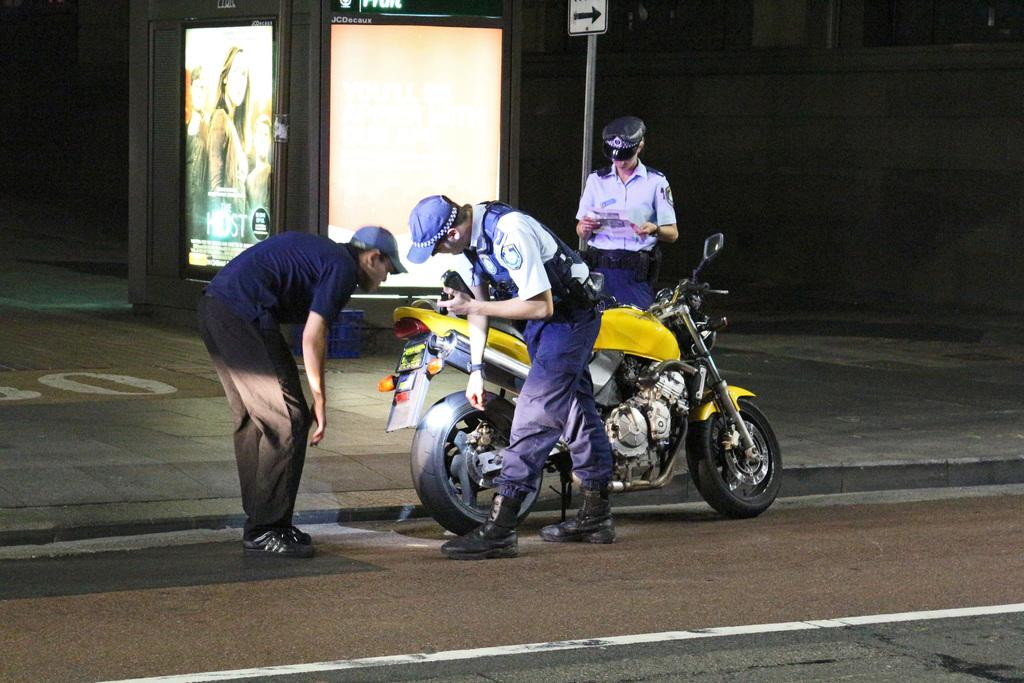How many men are standing on the road in the image? There are three men standing on the road in the image. What is the proximity of the men to each other? The men are standing close to each other. What is one man doing in the image? One man is watching a bike in the background. What objects can be seen in the background of the image? There is a screen and a board in the background. What type of wrench is the man using to fix the bike in the image? There is no man using a wrench to fix a bike in the image; one man is simply watching a bike in the background. How many children are playing near the men in the image? There are no children present in the image; it only features three men standing on the road. 